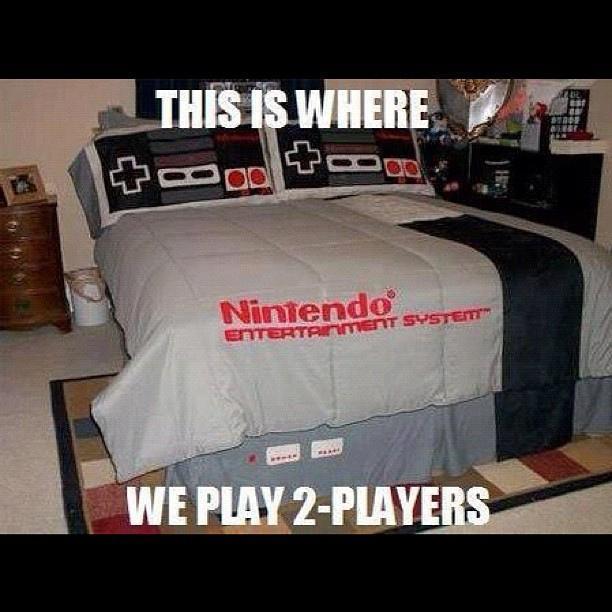How many train cars are in the picture?
Give a very brief answer. 0. 